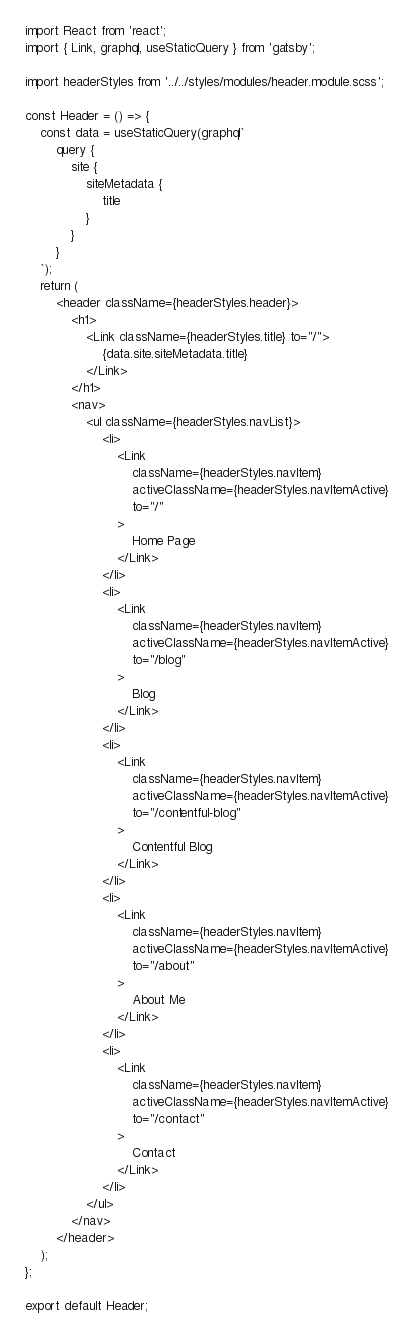<code> <loc_0><loc_0><loc_500><loc_500><_JavaScript_>import React from 'react';
import { Link, graphql, useStaticQuery } from 'gatsby';

import headerStyles from '../../styles/modules/header.module.scss';

const Header = () => {
	const data = useStaticQuery(graphql`
		query {
			site {
				siteMetadata {
					title
				}
			}
		}
	`);
	return (
		<header className={headerStyles.header}>
			<h1>
				<Link className={headerStyles.title} to="/">
					{data.site.siteMetadata.title}
				</Link>
			</h1>
			<nav>
				<ul className={headerStyles.navList}>
					<li>
						<Link
							className={headerStyles.navItem}
							activeClassName={headerStyles.navItemActive}
							to="/"
						>
							Home Page
						</Link>
					</li>
					<li>
						<Link
							className={headerStyles.navItem}
							activeClassName={headerStyles.navItemActive}
							to="/blog"
						>
							Blog
						</Link>
					</li>
					<li>
						<Link
							className={headerStyles.navItem}
							activeClassName={headerStyles.navItemActive}
							to="/contentful-blog"
						>
							Contentful Blog
						</Link>
					</li>
					<li>
						<Link
							className={headerStyles.navItem}
							activeClassName={headerStyles.navItemActive}
							to="/about"
						>
							About Me
						</Link>
					</li>
					<li>
						<Link
							className={headerStyles.navItem}
							activeClassName={headerStyles.navItemActive}
							to="/contact"
						>
							Contact
						</Link>
					</li>
				</ul>
			</nav>
		</header>
	);
};

export default Header;
</code> 